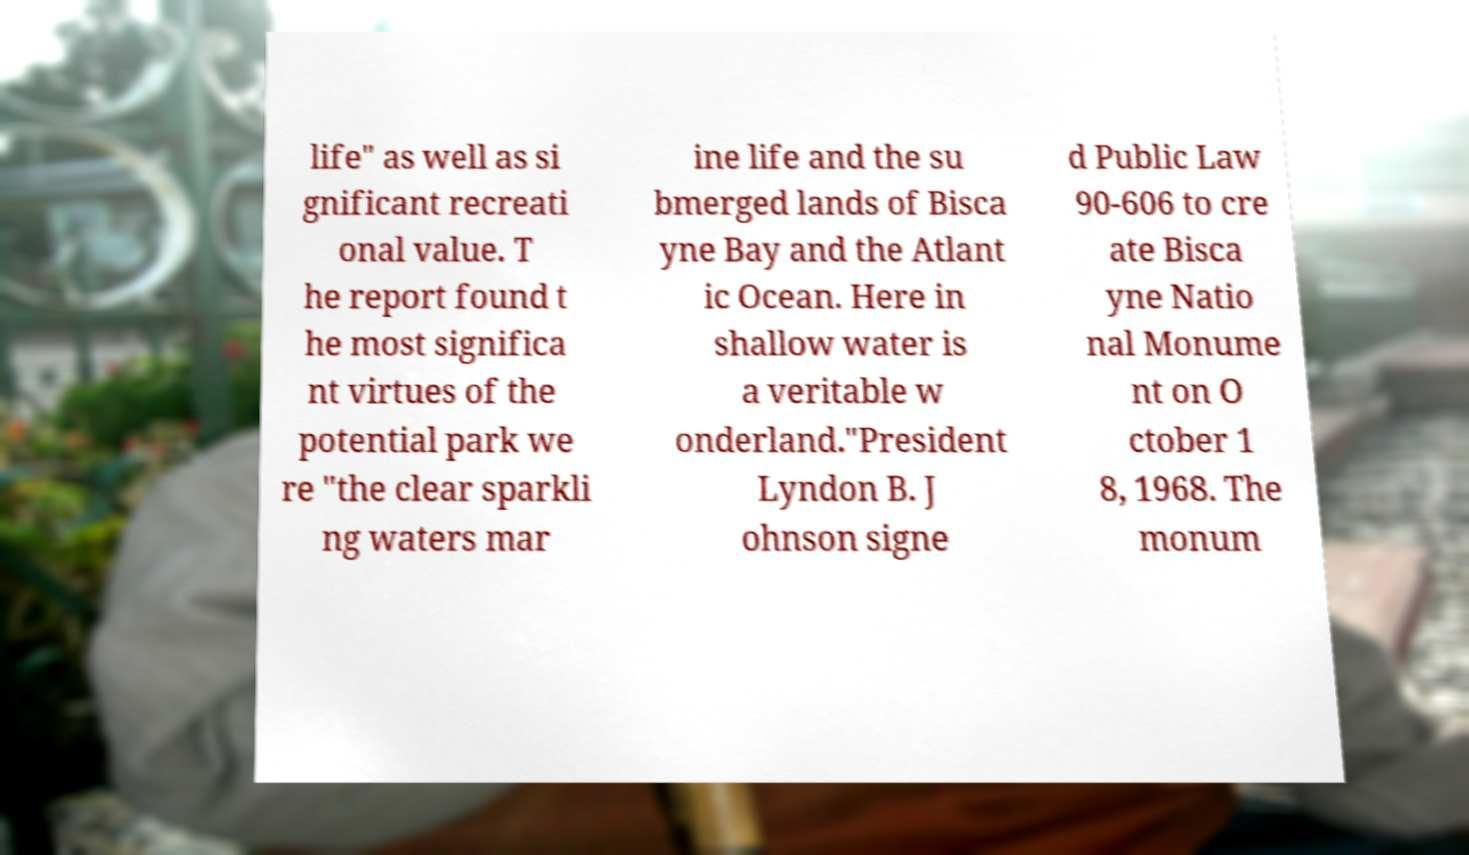Can you accurately transcribe the text from the provided image for me? life" as well as si gnificant recreati onal value. T he report found t he most significa nt virtues of the potential park we re "the clear sparkli ng waters mar ine life and the su bmerged lands of Bisca yne Bay and the Atlant ic Ocean. Here in shallow water is a veritable w onderland."President Lyndon B. J ohnson signe d Public Law 90-606 to cre ate Bisca yne Natio nal Monume nt on O ctober 1 8, 1968. The monum 